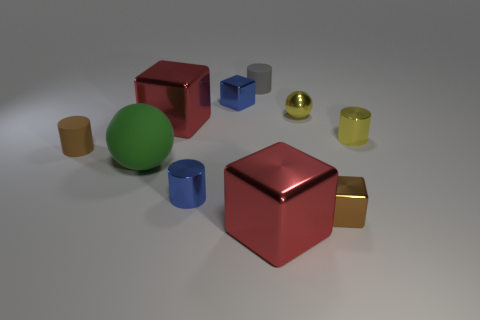How many small things are either objects or cyan things?
Keep it short and to the point. 7. Are there fewer small yellow shiny cylinders than tiny purple shiny balls?
Your answer should be compact. No. Is the color of the rubber ball the same as the shiny sphere?
Your answer should be very brief. No. Is the number of small rubber things greater than the number of cylinders?
Give a very brief answer. No. How many other things are there of the same color as the tiny sphere?
Provide a short and direct response. 1. There is a small blue metal object that is behind the tiny brown matte object; what number of things are in front of it?
Give a very brief answer. 8. Are there any red cubes in front of the small brown matte cylinder?
Your response must be concise. Yes. What is the shape of the brown thing that is behind the sphere that is in front of the tiny yellow ball?
Provide a short and direct response. Cylinder. Are there fewer tiny blue cubes in front of the tiny brown rubber cylinder than tiny gray rubber things in front of the tiny blue cylinder?
Your answer should be very brief. No. What is the color of the tiny shiny thing that is the same shape as the big green matte thing?
Provide a short and direct response. Yellow. 